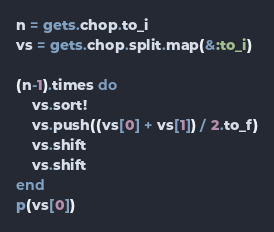Convert code to text. <code><loc_0><loc_0><loc_500><loc_500><_Ruby_>n = gets.chop.to_i
vs = gets.chop.split.map(&:to_i)

(n-1).times do
    vs.sort!
    vs.push((vs[0] + vs[1]) / 2.to_f)
    vs.shift
    vs.shift
end
p(vs[0])</code> 